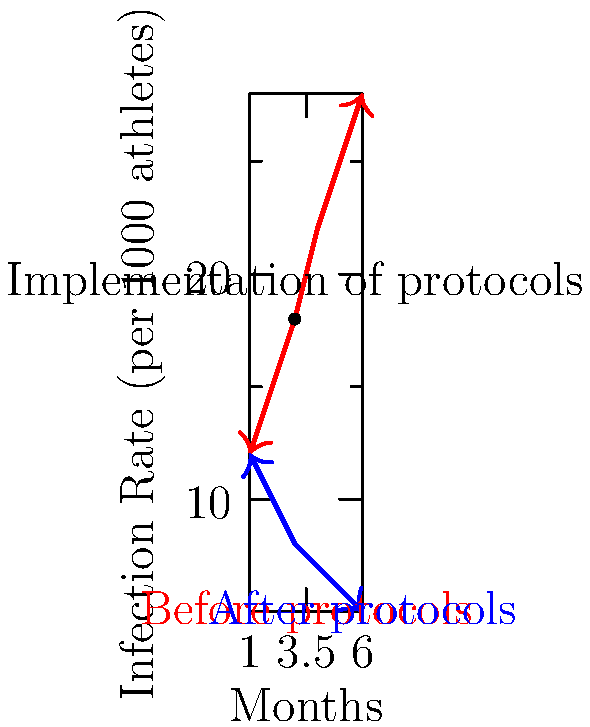Based on the line graph showing infection rates before and after implementing health protocols in sporting events, what was the approximate percentage reduction in infection rate by the end of the 6-month period? To calculate the percentage reduction in infection rate:

1. Identify the initial and final infection rates:
   - Initial rate (before protocols, month 1): 12 per 1000 athletes
   - Final rate (after protocols, month 6): 5 per 1000 athletes

2. Calculate the absolute reduction:
   $12 - 5 = 7$ per 1000 athletes

3. Calculate the percentage reduction:
   Percentage reduction = $\frac{\text{Reduction}}{\text{Initial rate}} \times 100\%$
   $= \frac{7}{12} \times 100\% = 58.33\%$

4. Round to the nearest whole number:
   $58.33\% \approx 58\%$

Therefore, the approximate percentage reduction in infection rate by the end of the 6-month period was 58%.
Answer: 58% 